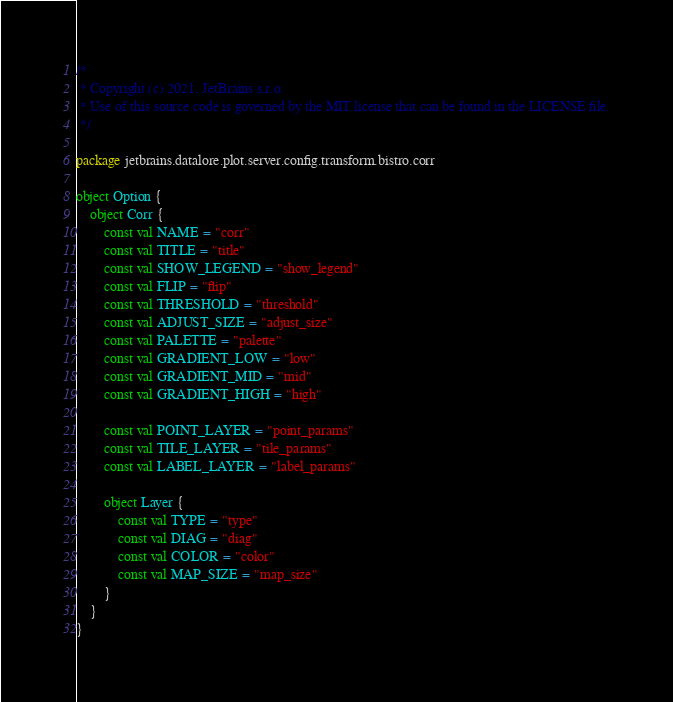<code> <loc_0><loc_0><loc_500><loc_500><_Kotlin_>/*
 * Copyright (c) 2021. JetBrains s.r.o.
 * Use of this source code is governed by the MIT license that can be found in the LICENSE file.
 */

package jetbrains.datalore.plot.server.config.transform.bistro.corr

object Option {
    object Corr {
        const val NAME = "corr"
        const val TITLE = "title"
        const val SHOW_LEGEND = "show_legend"
        const val FLIP = "flip"
        const val THRESHOLD = "threshold"
        const val ADJUST_SIZE = "adjust_size"
        const val PALETTE = "palette"
        const val GRADIENT_LOW = "low"
        const val GRADIENT_MID = "mid"
        const val GRADIENT_HIGH = "high"

        const val POINT_LAYER = "point_params"
        const val TILE_LAYER = "tile_params"
        const val LABEL_LAYER = "label_params"

        object Layer {
            const val TYPE = "type"
            const val DIAG = "diag"
            const val COLOR = "color"
            const val MAP_SIZE = "map_size"
        }
    }
}
</code> 